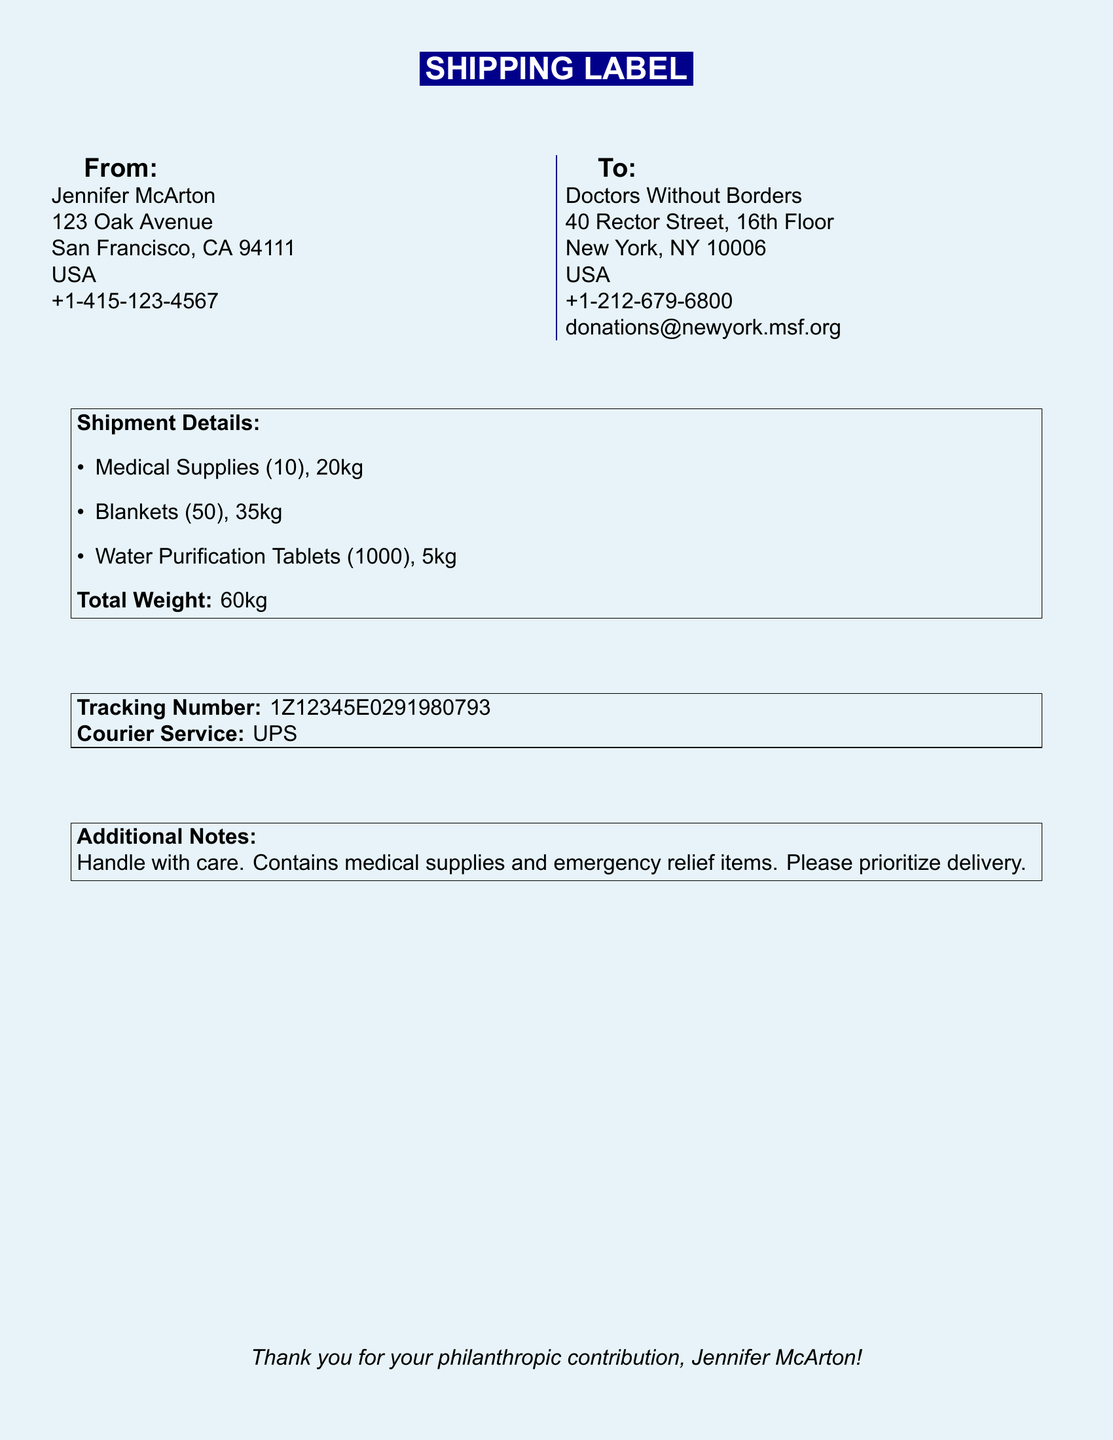what is the name of the charity? The charity is named "Doctors Without Borders," which is listed in the "To" section of the document.
Answer: Doctors Without Borders how many medical supplies are included? The document states that there are 10 medical supplies under the "Shipment Details" section.
Answer: 10 what is the total weight of the shipment? The total weight is found at the bottom of the "Shipment Details" and is clearly mentioned.
Answer: 60kg what is the courier service used for the shipment? The courier service is specified in the "Tracking Number" section of the document.
Answer: UPS what is the address of Jennifer McArton? Jennifer McArton's address is outlined in the "From" section of the document.
Answer: 123 Oak Avenue, San Francisco, CA 94111 how many blankets were donated? The number of blankets is detailed in the "Shipment Details" as part of the listed items.
Answer: 50 who should the additional delivery notes be directed to? The additional notes indicate handling instructions and can be assumed to be directed at the courier.
Answer: Courier what is the tracking number? The tracking number is explicitly presented in the "Tracking Number" box of the document.
Answer: 1Z12345E0291980793 what city is Doctors Without Borders located in? The address indicates that Doctors Without Borders is located in New York, which is stated in the "To" section.
Answer: New York 